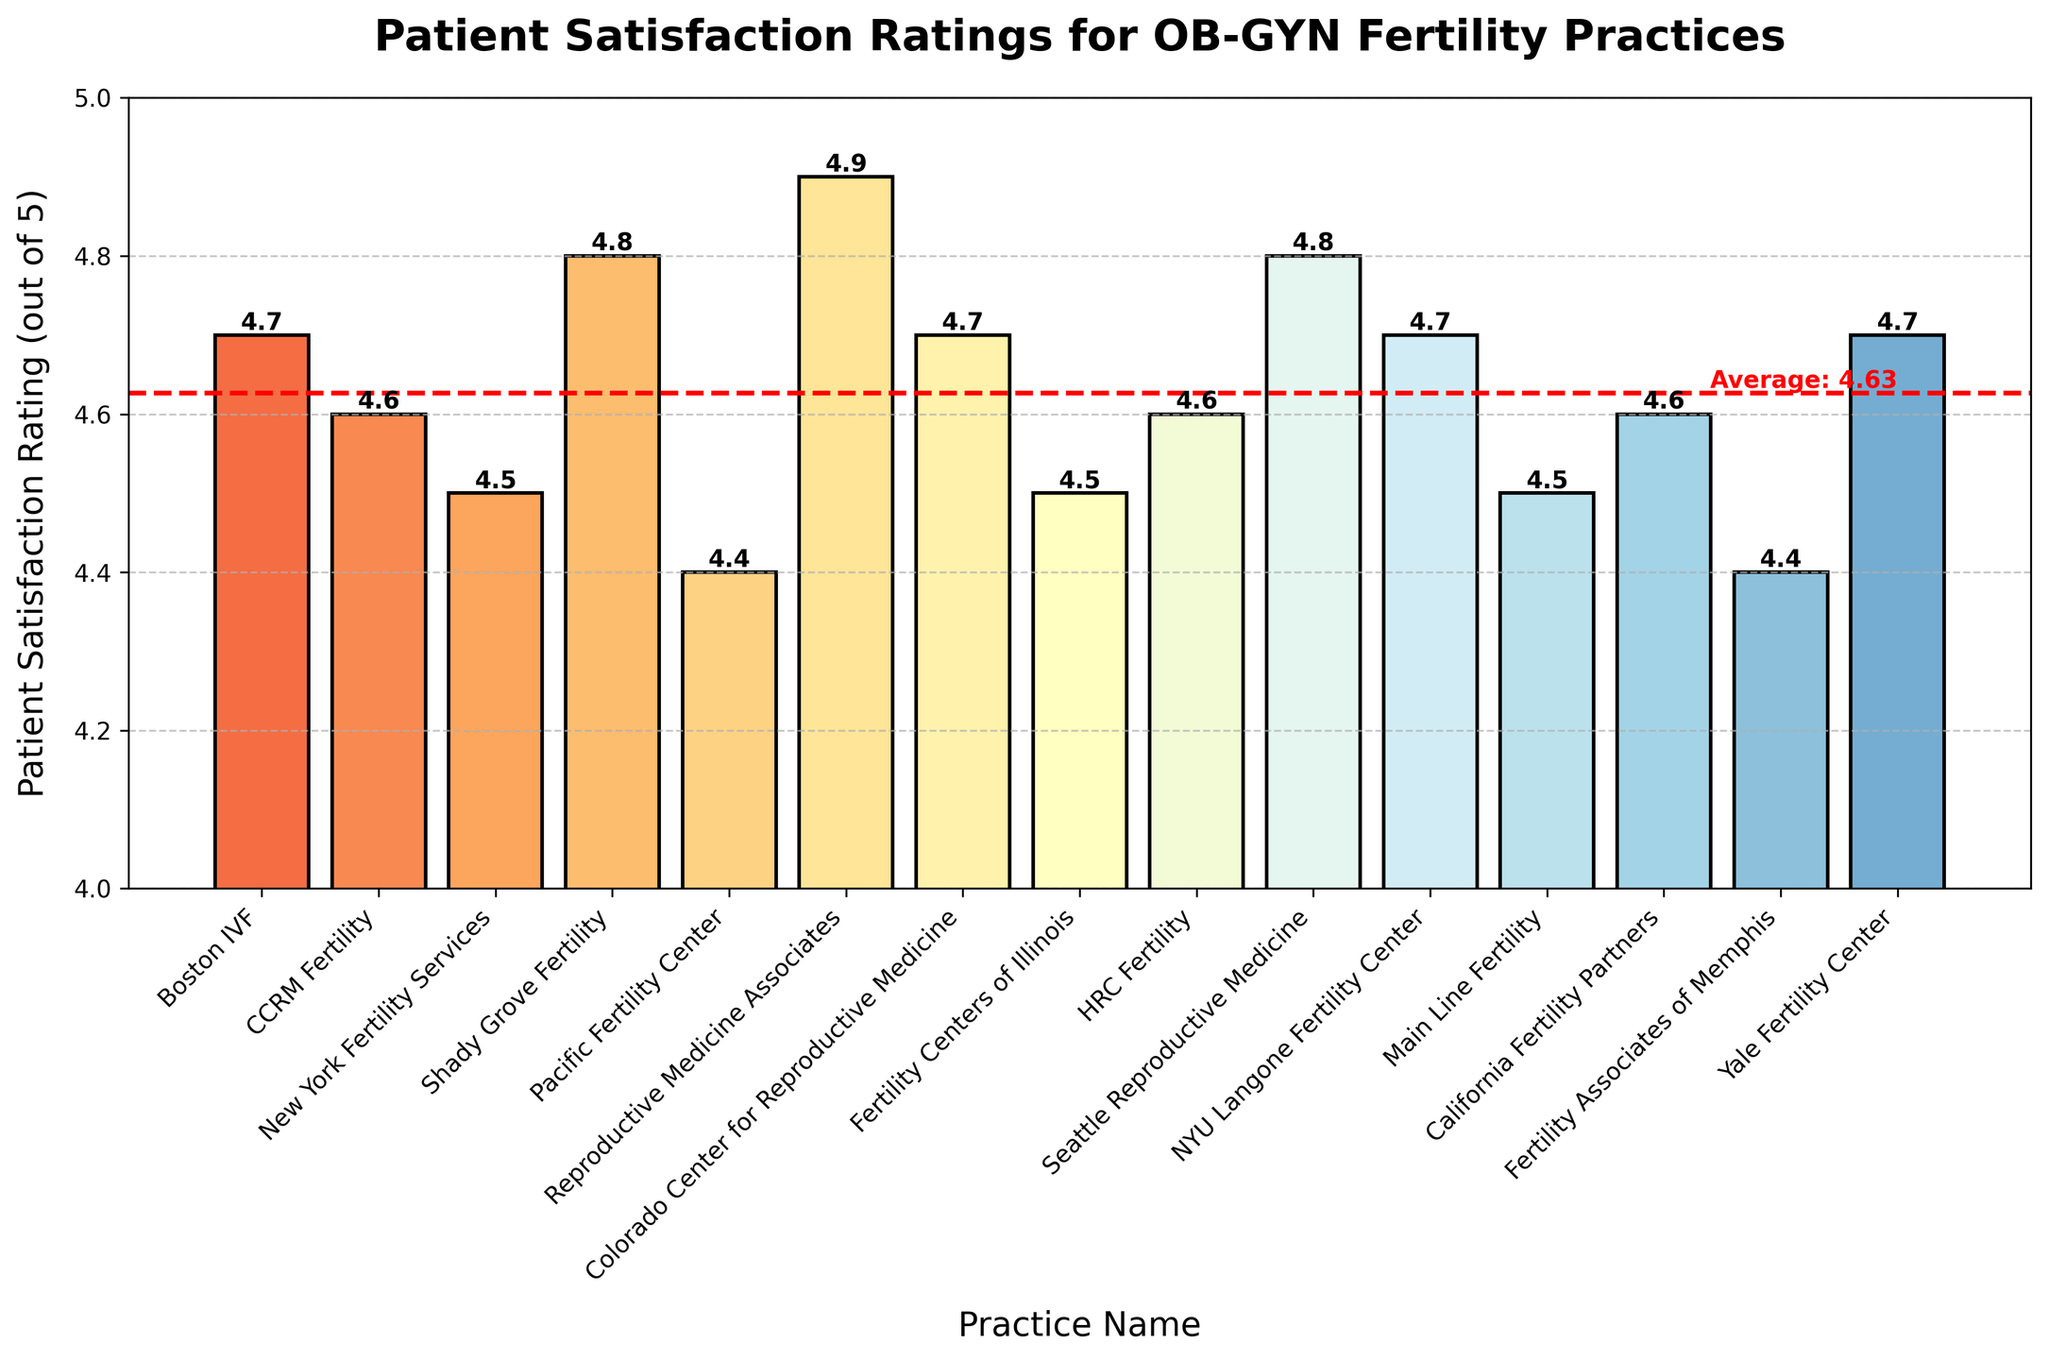What's the highest patient satisfaction rating among the practices? The highest patient satisfaction rating can be found by identifying the tallest bar in the chart. By observing, Reproductive Medicine Associates has the highest bar with a rating of 4.9.
Answer: 4.9 Which practice has the lowest patient satisfaction rating? To find the lowest patient satisfaction rating, look for the shortest bar in the chart. Pacific Fertility Center and Fertility Associates of Memphis have the shortest bars with a rating of 4.4.
Answer: Pacific Fertility Center and Fertility Associates of Memphis How many practices have a satisfaction rating of 4.7? To determine the number of practices with a rating of 4.7, count the number of bars that reach the 4.7 mark. These practices are Boston IVF, Colorado Center for Reproductive Medicine, NYU Langone Fertility Center, and Yale Fertility Center.
Answer: 4 Which practices have a satisfaction rating equal to the average rating? First, identify the average rating from the red horizontal line labeled "Average: 4.6". Then, look for bars that reach the 4.6 mark. The practices that match this are CCRM Fertility, HRC Fertility, and California Fertility Partners.
Answer: CCRM Fertility, HRC Fertility, and California Fertility Partners What is the difference in satisfaction ratings between the highest and lowest-rated practices? The highest rating is 4.9 (Reproductive Medicine Associates) and the lowest is 4.4 (Pacific Fertility Center and Fertility Associates of Memphis). Subtract 4.4 from 4.9 to find the difference. 4.9 - 4.4 = 0.5.
Answer: 0.5 How do the satisfaction ratings of Seattle Reproductive Medicine and CCRM Fertility compare? To compare, check the bars representing Seattle Reproductive Medicine and CCRM Fertility. Seattle Reproductive Medicine has a rating of 4.8 while CCRM Fertility has a rating of 4.6. 4.8 is greater than 4.6.
Answer: Seattle Reproductive Medicine has a higher rating What practices rate above the average satisfaction rating? Identify all bars taller than the red average line (4.6). The practices above the average are Reproductive Medicine Associates, Shady Grove Fertility, Seattle Reproductive Medicine, Boston IVF, Colorado Center for Reproductive Medicine, NYU Langone Fertility Center, and Yale Fertility Center.
Answer: Reproductive Medicine Associates, Shady Grove Fertility, Seattle Reproductive Medicine, Boston IVF, Colorado Center for Reproductive Medicine, NYU Langone Fertility Center, and Yale Fertility Center Which two practices have the same satisfaction rating but one has its bar slightly towards the right? Look for bars with the same height indicating the same rating. Boston IVF and Colorado Center for Reproductive Medicine both have a rating of 4.7; Colorado Center for Reproductive Medicine is slightly to the right of Boston IVF.
Answer: Boston IVF and Colorado Center for Reproductive Medicine What's the average satisfaction rating of all the practices combined? The average rating is visually indicated by the red horizontal line on the chart, which is labeled as "Average: 4.6," thus confirming that the average rating of all practices combined is 4.6.
Answer: 4.6 